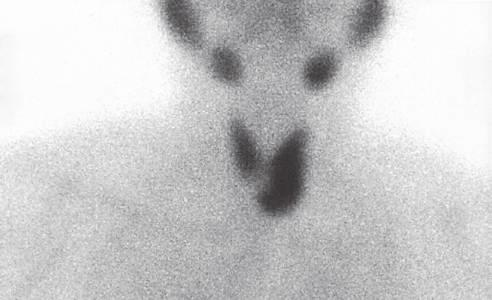what demonstrates an area of increased uptake corresponding to the left inferior parathyroid gland (arrow)?
Answer the question using a single word or phrase. Technetium-99 radionuclide scan 